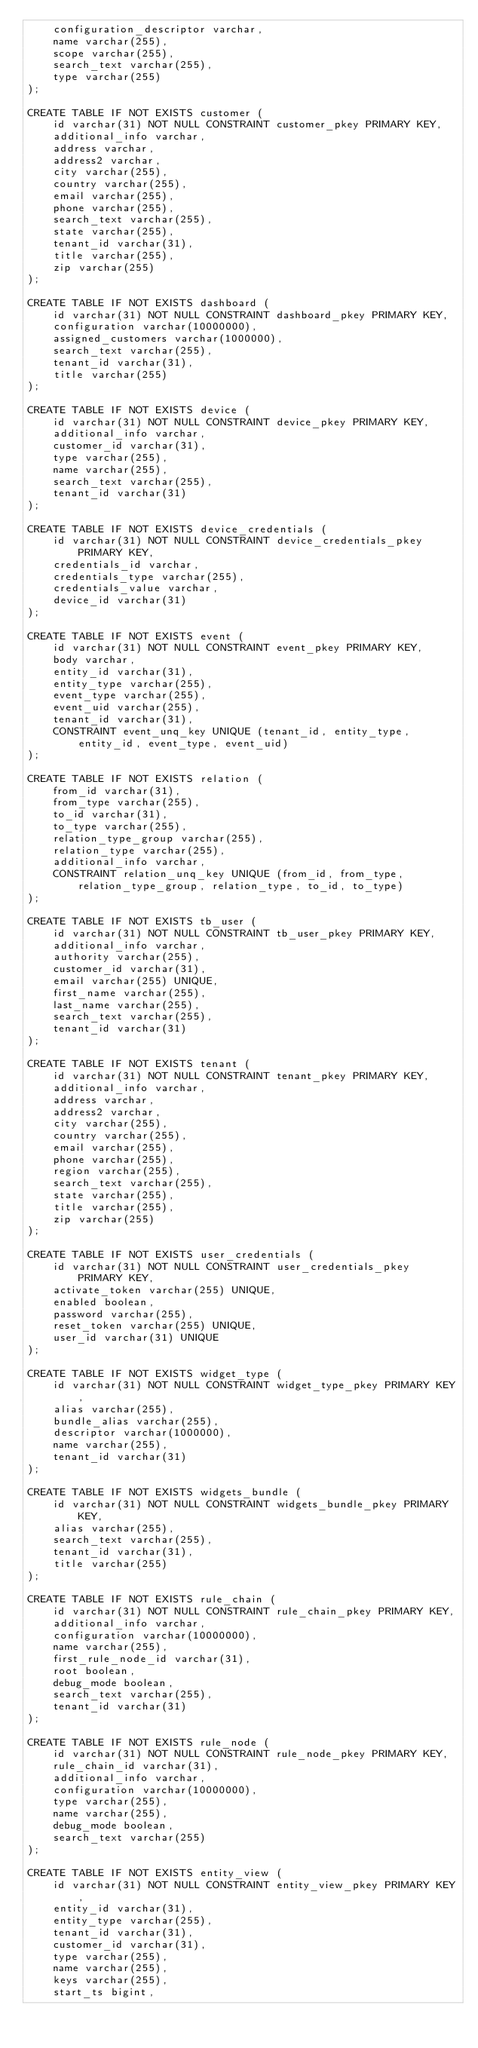<code> <loc_0><loc_0><loc_500><loc_500><_SQL_>    configuration_descriptor varchar,
    name varchar(255),
    scope varchar(255),
    search_text varchar(255),
    type varchar(255)
);

CREATE TABLE IF NOT EXISTS customer (
    id varchar(31) NOT NULL CONSTRAINT customer_pkey PRIMARY KEY,
    additional_info varchar,
    address varchar,
    address2 varchar,
    city varchar(255),
    country varchar(255),
    email varchar(255),
    phone varchar(255),
    search_text varchar(255),
    state varchar(255),
    tenant_id varchar(31),
    title varchar(255),
    zip varchar(255)
);

CREATE TABLE IF NOT EXISTS dashboard (
    id varchar(31) NOT NULL CONSTRAINT dashboard_pkey PRIMARY KEY,
    configuration varchar(10000000),
    assigned_customers varchar(1000000),
    search_text varchar(255),
    tenant_id varchar(31),
    title varchar(255)
);

CREATE TABLE IF NOT EXISTS device (
    id varchar(31) NOT NULL CONSTRAINT device_pkey PRIMARY KEY,
    additional_info varchar,
    customer_id varchar(31),
    type varchar(255),
    name varchar(255),
    search_text varchar(255),
    tenant_id varchar(31)
);

CREATE TABLE IF NOT EXISTS device_credentials (
    id varchar(31) NOT NULL CONSTRAINT device_credentials_pkey PRIMARY KEY,
    credentials_id varchar,
    credentials_type varchar(255),
    credentials_value varchar,
    device_id varchar(31)
);

CREATE TABLE IF NOT EXISTS event (
    id varchar(31) NOT NULL CONSTRAINT event_pkey PRIMARY KEY,
    body varchar,
    entity_id varchar(31),
    entity_type varchar(255),
    event_type varchar(255),
    event_uid varchar(255),
    tenant_id varchar(31),
    CONSTRAINT event_unq_key UNIQUE (tenant_id, entity_type, entity_id, event_type, event_uid)
);

CREATE TABLE IF NOT EXISTS relation (
    from_id varchar(31),
    from_type varchar(255),
    to_id varchar(31),
    to_type varchar(255),
    relation_type_group varchar(255),
    relation_type varchar(255),
    additional_info varchar,
    CONSTRAINT relation_unq_key UNIQUE (from_id, from_type, relation_type_group, relation_type, to_id, to_type)
);

CREATE TABLE IF NOT EXISTS tb_user (
    id varchar(31) NOT NULL CONSTRAINT tb_user_pkey PRIMARY KEY,
    additional_info varchar,
    authority varchar(255),
    customer_id varchar(31),
    email varchar(255) UNIQUE,
    first_name varchar(255),
    last_name varchar(255),
    search_text varchar(255),
    tenant_id varchar(31)
);

CREATE TABLE IF NOT EXISTS tenant (
    id varchar(31) NOT NULL CONSTRAINT tenant_pkey PRIMARY KEY,
    additional_info varchar,
    address varchar,
    address2 varchar,
    city varchar(255),
    country varchar(255),
    email varchar(255),
    phone varchar(255),
    region varchar(255),
    search_text varchar(255),
    state varchar(255),
    title varchar(255),
    zip varchar(255)
);

CREATE TABLE IF NOT EXISTS user_credentials (
    id varchar(31) NOT NULL CONSTRAINT user_credentials_pkey PRIMARY KEY,
    activate_token varchar(255) UNIQUE,
    enabled boolean,
    password varchar(255),
    reset_token varchar(255) UNIQUE,
    user_id varchar(31) UNIQUE
);

CREATE TABLE IF NOT EXISTS widget_type (
    id varchar(31) NOT NULL CONSTRAINT widget_type_pkey PRIMARY KEY,
    alias varchar(255),
    bundle_alias varchar(255),
    descriptor varchar(1000000),
    name varchar(255),
    tenant_id varchar(31)
);

CREATE TABLE IF NOT EXISTS widgets_bundle (
    id varchar(31) NOT NULL CONSTRAINT widgets_bundle_pkey PRIMARY KEY,
    alias varchar(255),
    search_text varchar(255),
    tenant_id varchar(31),
    title varchar(255)
);

CREATE TABLE IF NOT EXISTS rule_chain (
    id varchar(31) NOT NULL CONSTRAINT rule_chain_pkey PRIMARY KEY,
    additional_info varchar,
    configuration varchar(10000000),
    name varchar(255),
    first_rule_node_id varchar(31),
    root boolean,
    debug_mode boolean,
    search_text varchar(255),
    tenant_id varchar(31)
);

CREATE TABLE IF NOT EXISTS rule_node (
    id varchar(31) NOT NULL CONSTRAINT rule_node_pkey PRIMARY KEY,
    rule_chain_id varchar(31),
    additional_info varchar,
    configuration varchar(10000000),
    type varchar(255),
    name varchar(255),
    debug_mode boolean,
    search_text varchar(255)
);

CREATE TABLE IF NOT EXISTS entity_view (
    id varchar(31) NOT NULL CONSTRAINT entity_view_pkey PRIMARY KEY,
    entity_id varchar(31),
    entity_type varchar(255),
    tenant_id varchar(31),
    customer_id varchar(31),
    type varchar(255),
    name varchar(255),
    keys varchar(255),
    start_ts bigint,</code> 